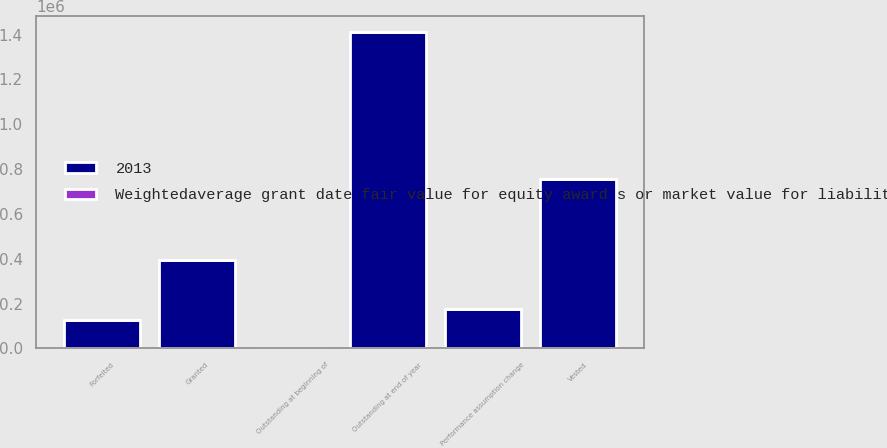Convert chart to OTSL. <chart><loc_0><loc_0><loc_500><loc_500><stacked_bar_chart><ecel><fcel>Outstanding at beginning of<fcel>Granted<fcel>Performance assumption change<fcel>Vested<fcel>Forfeited<fcel>Outstanding at end of year<nl><fcel>2013<fcel>88.49<fcel>395862<fcel>176534<fcel>754991<fcel>126583<fcel>1.4114e+06<nl><fcel>Weightedaverage grant date fair value for equity award s or market value for liability award s<fcel>56.71<fcel>88.49<fcel>84.27<fcel>50.33<fcel>71.8<fcel>72.43<nl></chart> 